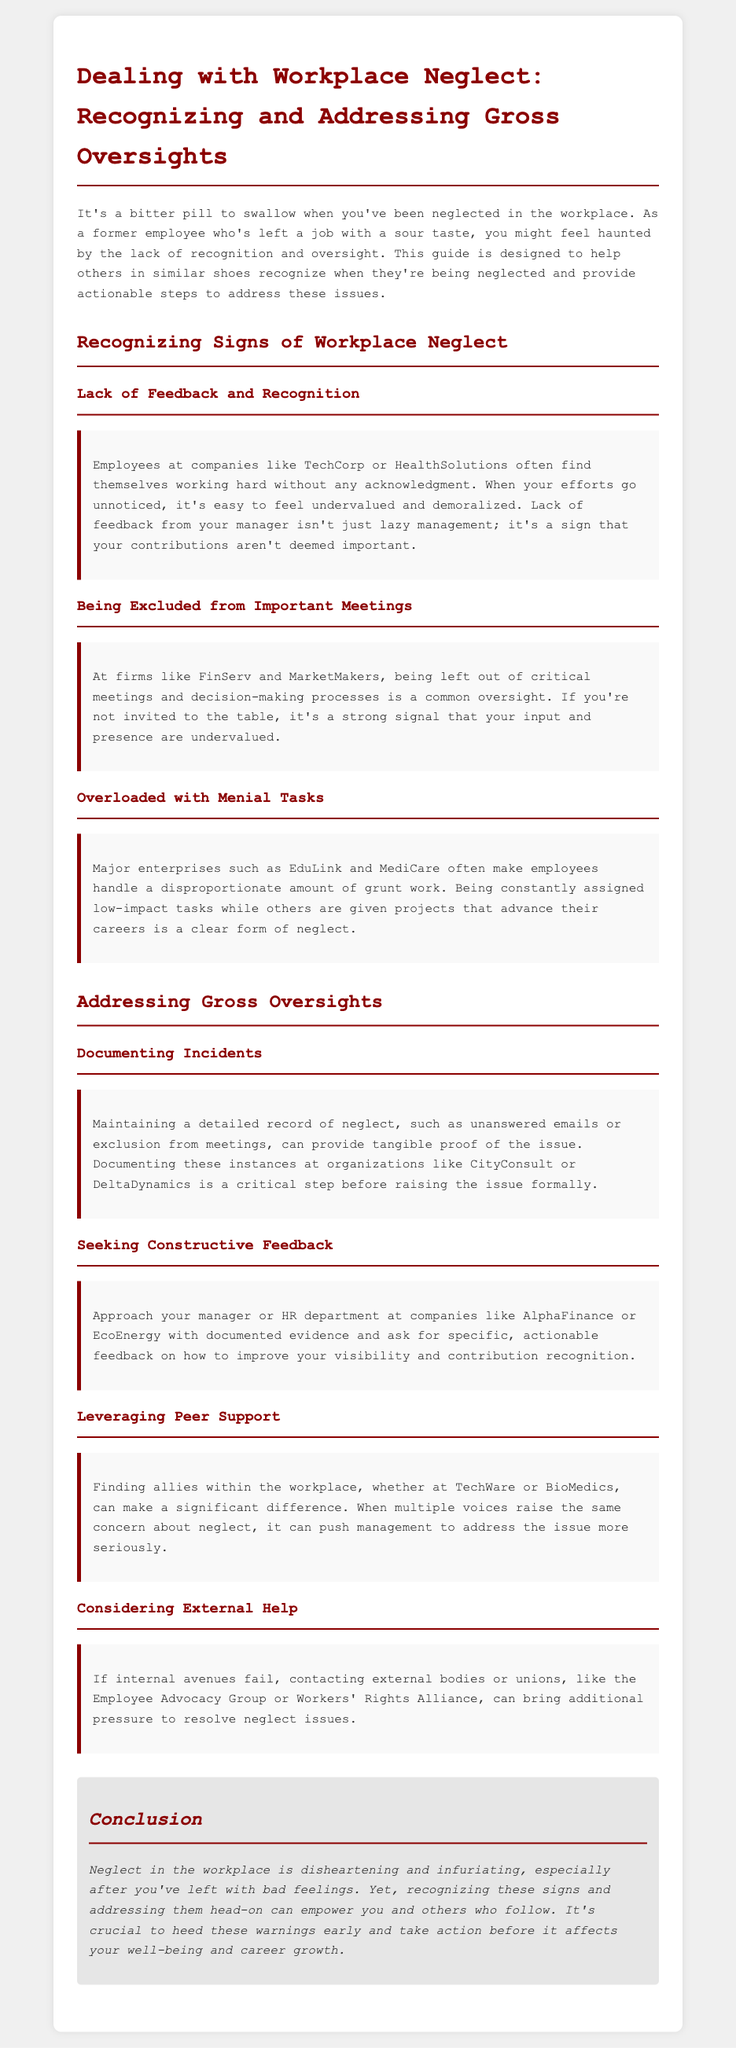what is the title of the document? The title is specified at the top of the document within the `<title>` tag.
Answer: Dealing with Workplace Neglect: Recognizing and Addressing Gross Oversights who is mentioned as a common example of workplace neglect? The document lists specific companies as examples of neglect in the workplace.
Answer: TechCorp what should you maintain to document neglect incidents? The document suggests a specific type of record needed for incidents.
Answer: Detailed record which companies are suggested for seeking feedback? The document points out companies where this action can be taken.
Answer: AlphaFinance, EcoEnergy name a potential action if internal avenues fail. The guide outlines steps to take when internal efforts do not yield results.
Answer: Contacting external bodies what is a sign of being undervalued at work? The document provides specific behaviors that indicate neglect.
Answer: Lack of feedback how can peer support help in addressing workplace neglect? The guide explains the importance of this aspect in use of resources.
Answer: Push management to address issues what can workers do to improve recognition? The guide provides actions employees may take for better acknowledgment.
Answer: Seek constructive feedback 